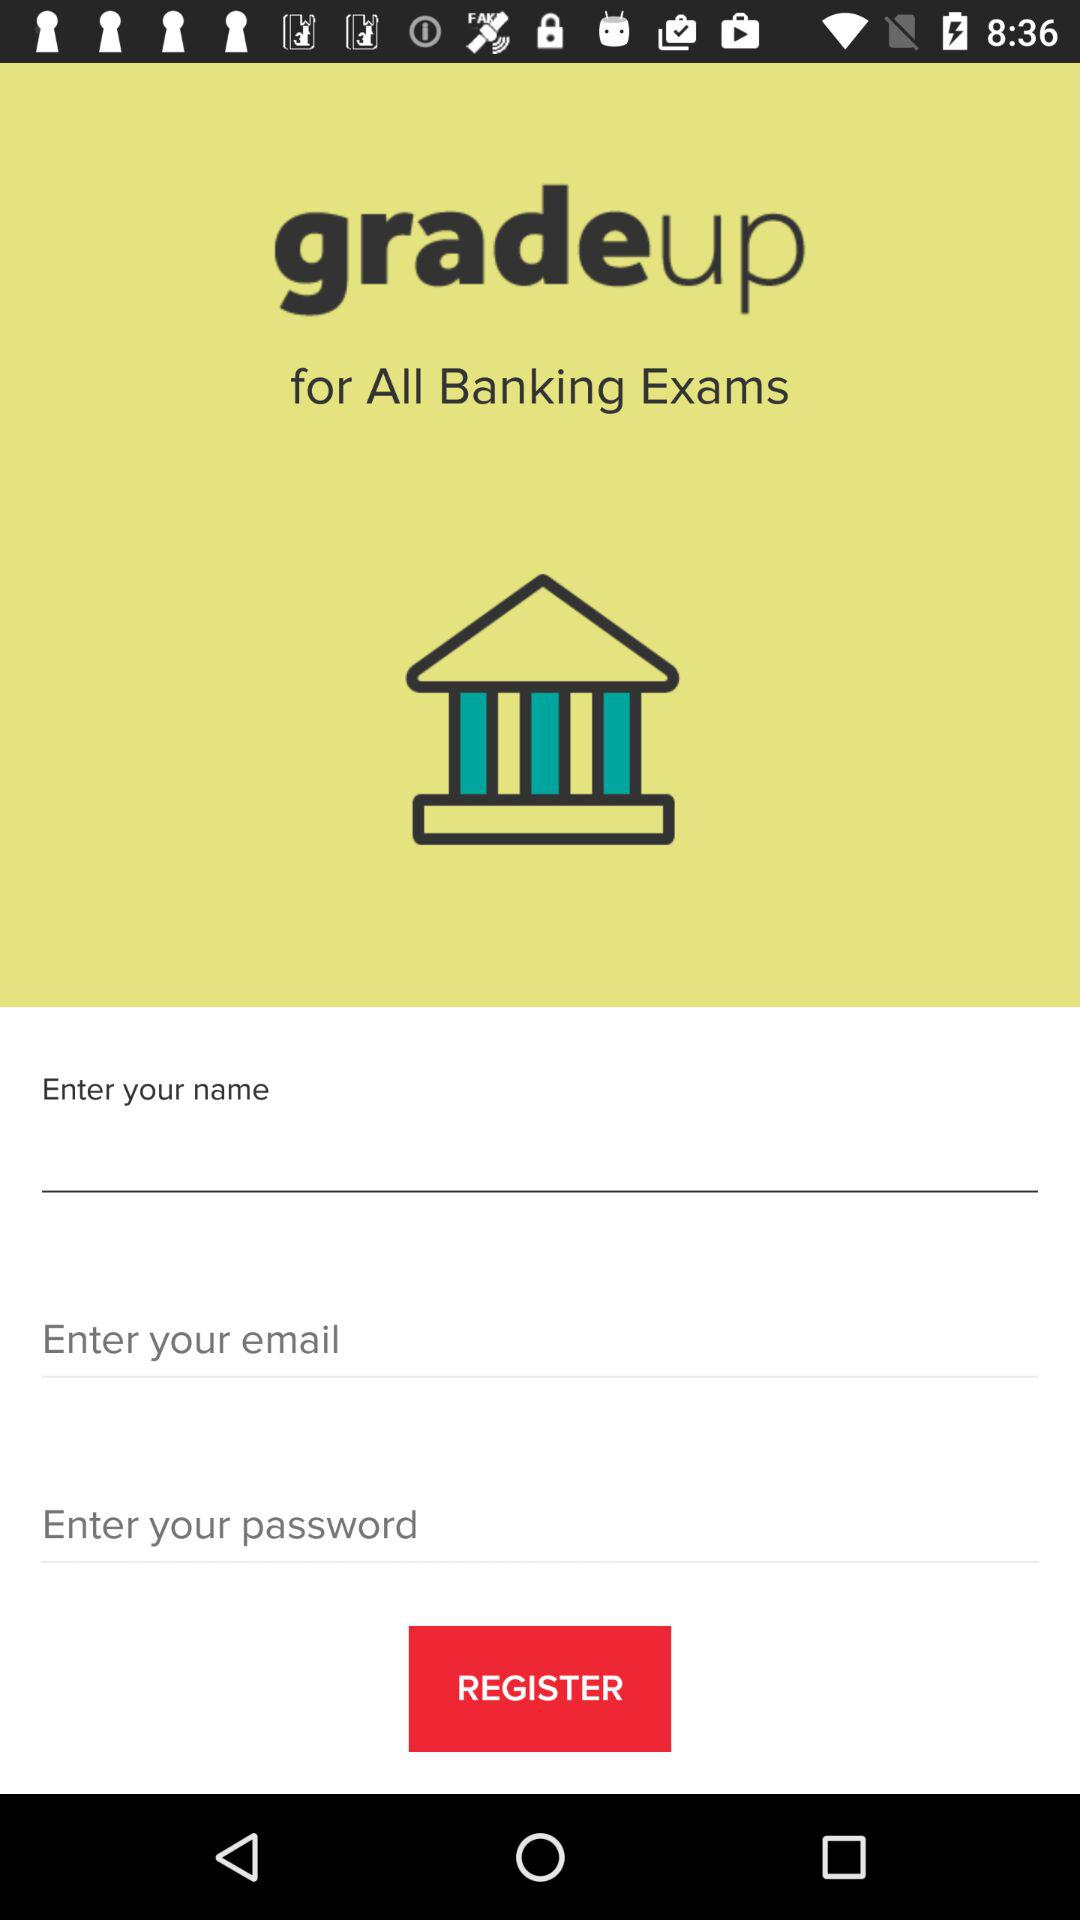How many text fields are there in the form?
Answer the question using a single word or phrase. 3 